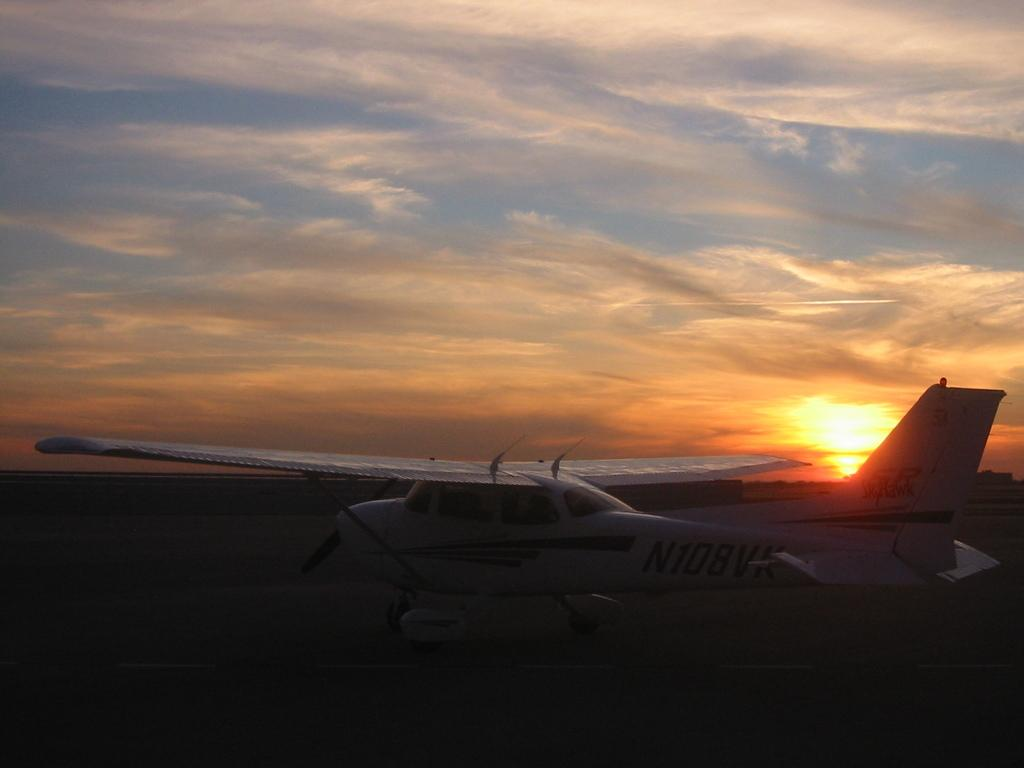What can be seen in the sky in the image? There are clouds, lightning, and the sun visible in the sky in the image. What is the condition of the sky in the image? The sky in the image has clouds, lightning, and the sun, which suggests a stormy or unsettled weather condition. What is present on the ground in the image? There is a road in the image. What is flying in the sky in the image? There is an airplane in the image. What is the color of the airplane in the image? The airplane is white in color. What channel is the airplane tuned to in the image? There is no indication in the image that the airplane is tuned to any channel, as airplanes do not have channels like televisions or radios. What type of scissors can be seen cutting the lightning in the image? There are no scissors present in the image, and the lightning is a natural phenomenon that cannot be cut by scissors. 